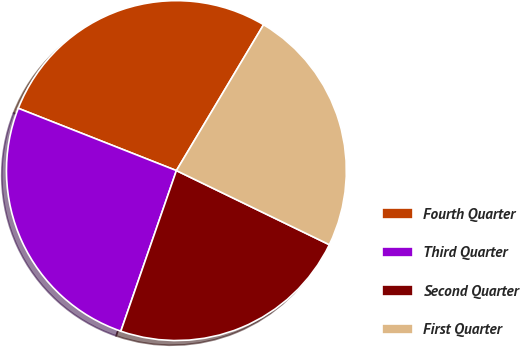Convert chart to OTSL. <chart><loc_0><loc_0><loc_500><loc_500><pie_chart><fcel>Fourth Quarter<fcel>Third Quarter<fcel>Second Quarter<fcel>First Quarter<nl><fcel>27.6%<fcel>25.67%<fcel>23.12%<fcel>23.61%<nl></chart> 